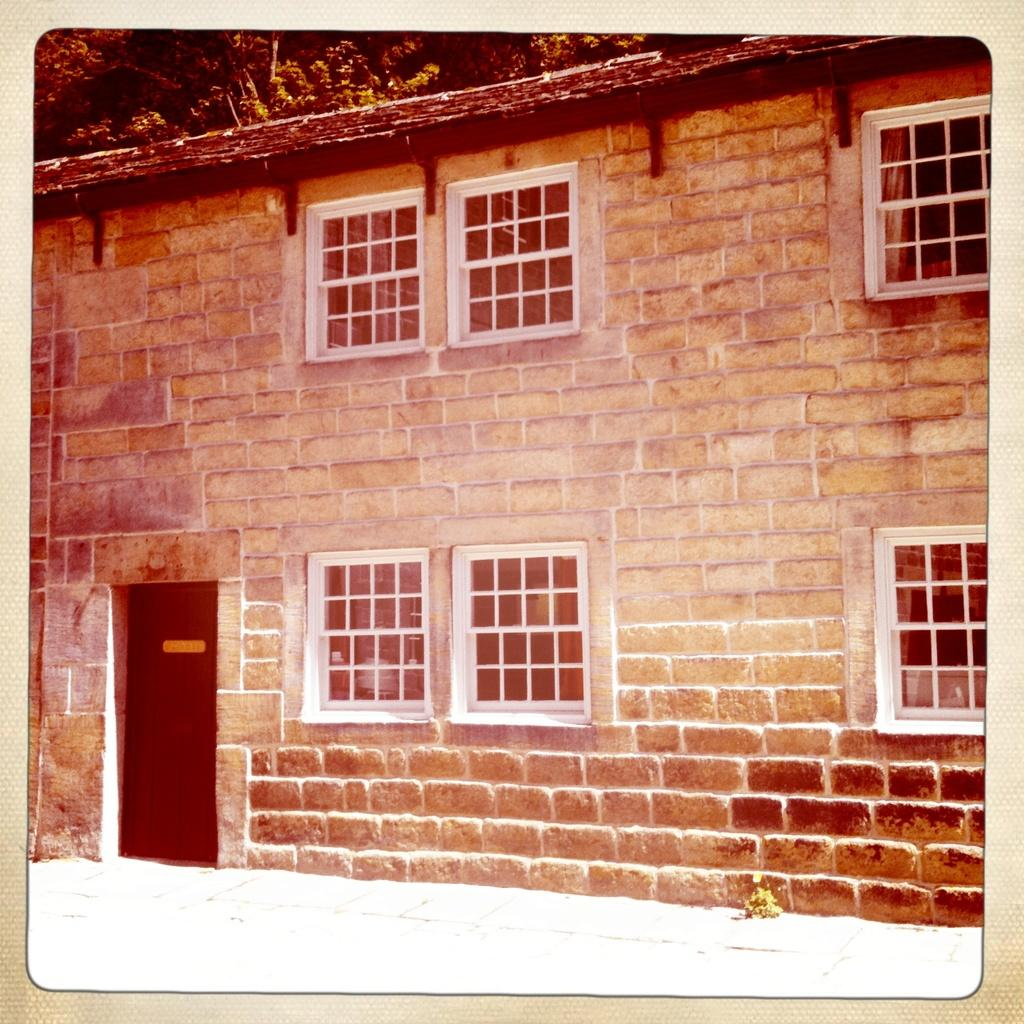What can be said about the age of the image? The image is an old image. What type of wall is visible in the image? There is a brown brick wall in the image. What is the color and material of the window in the image? There is a white window glass in the image. What type of camp can be seen in the image? There is no camp present in the image; it features a brown brick wall and a white window glass. What list is being referenced in the image? There is no list mentioned or depicted in the image. 